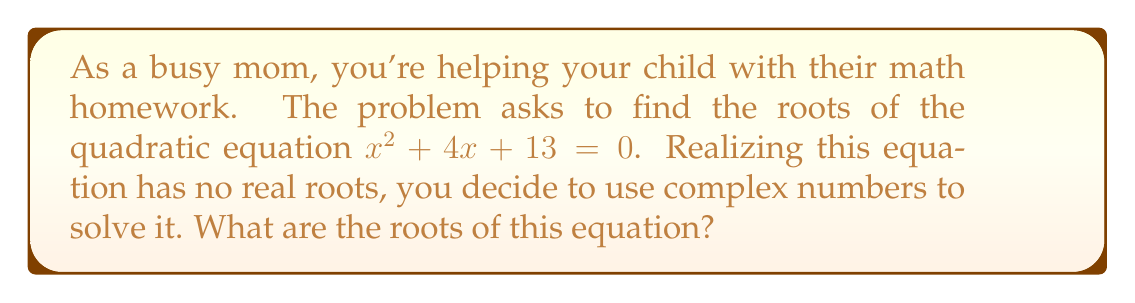Provide a solution to this math problem. Let's solve this step-by-step:

1) The quadratic equation is in the form $ax^2 + bx + c = 0$, where:
   $a = 1$, $b = 4$, and $c = 13$

2) We use the quadratic formula: $x = \frac{-b \pm \sqrt{b^2 - 4ac}}{2a}$

3) Let's calculate the discriminant $b^2 - 4ac$:
   $b^2 - 4ac = 4^2 - 4(1)(13) = 16 - 52 = -36$

4) Since the discriminant is negative, we know the roots will be complex.

5) Substituting into the quadratic formula:
   $x = \frac{-4 \pm \sqrt{-36}}{2(1)} = \frac{-4 \pm 6i}{2}$

6) Simplifying:
   $x = -2 \pm 3i$

7) Therefore, the two roots are:
   $x_1 = -2 + 3i$ and $x_2 = -2 - 3i$
Answer: $-2 + 3i$ and $-2 - 3i$ 